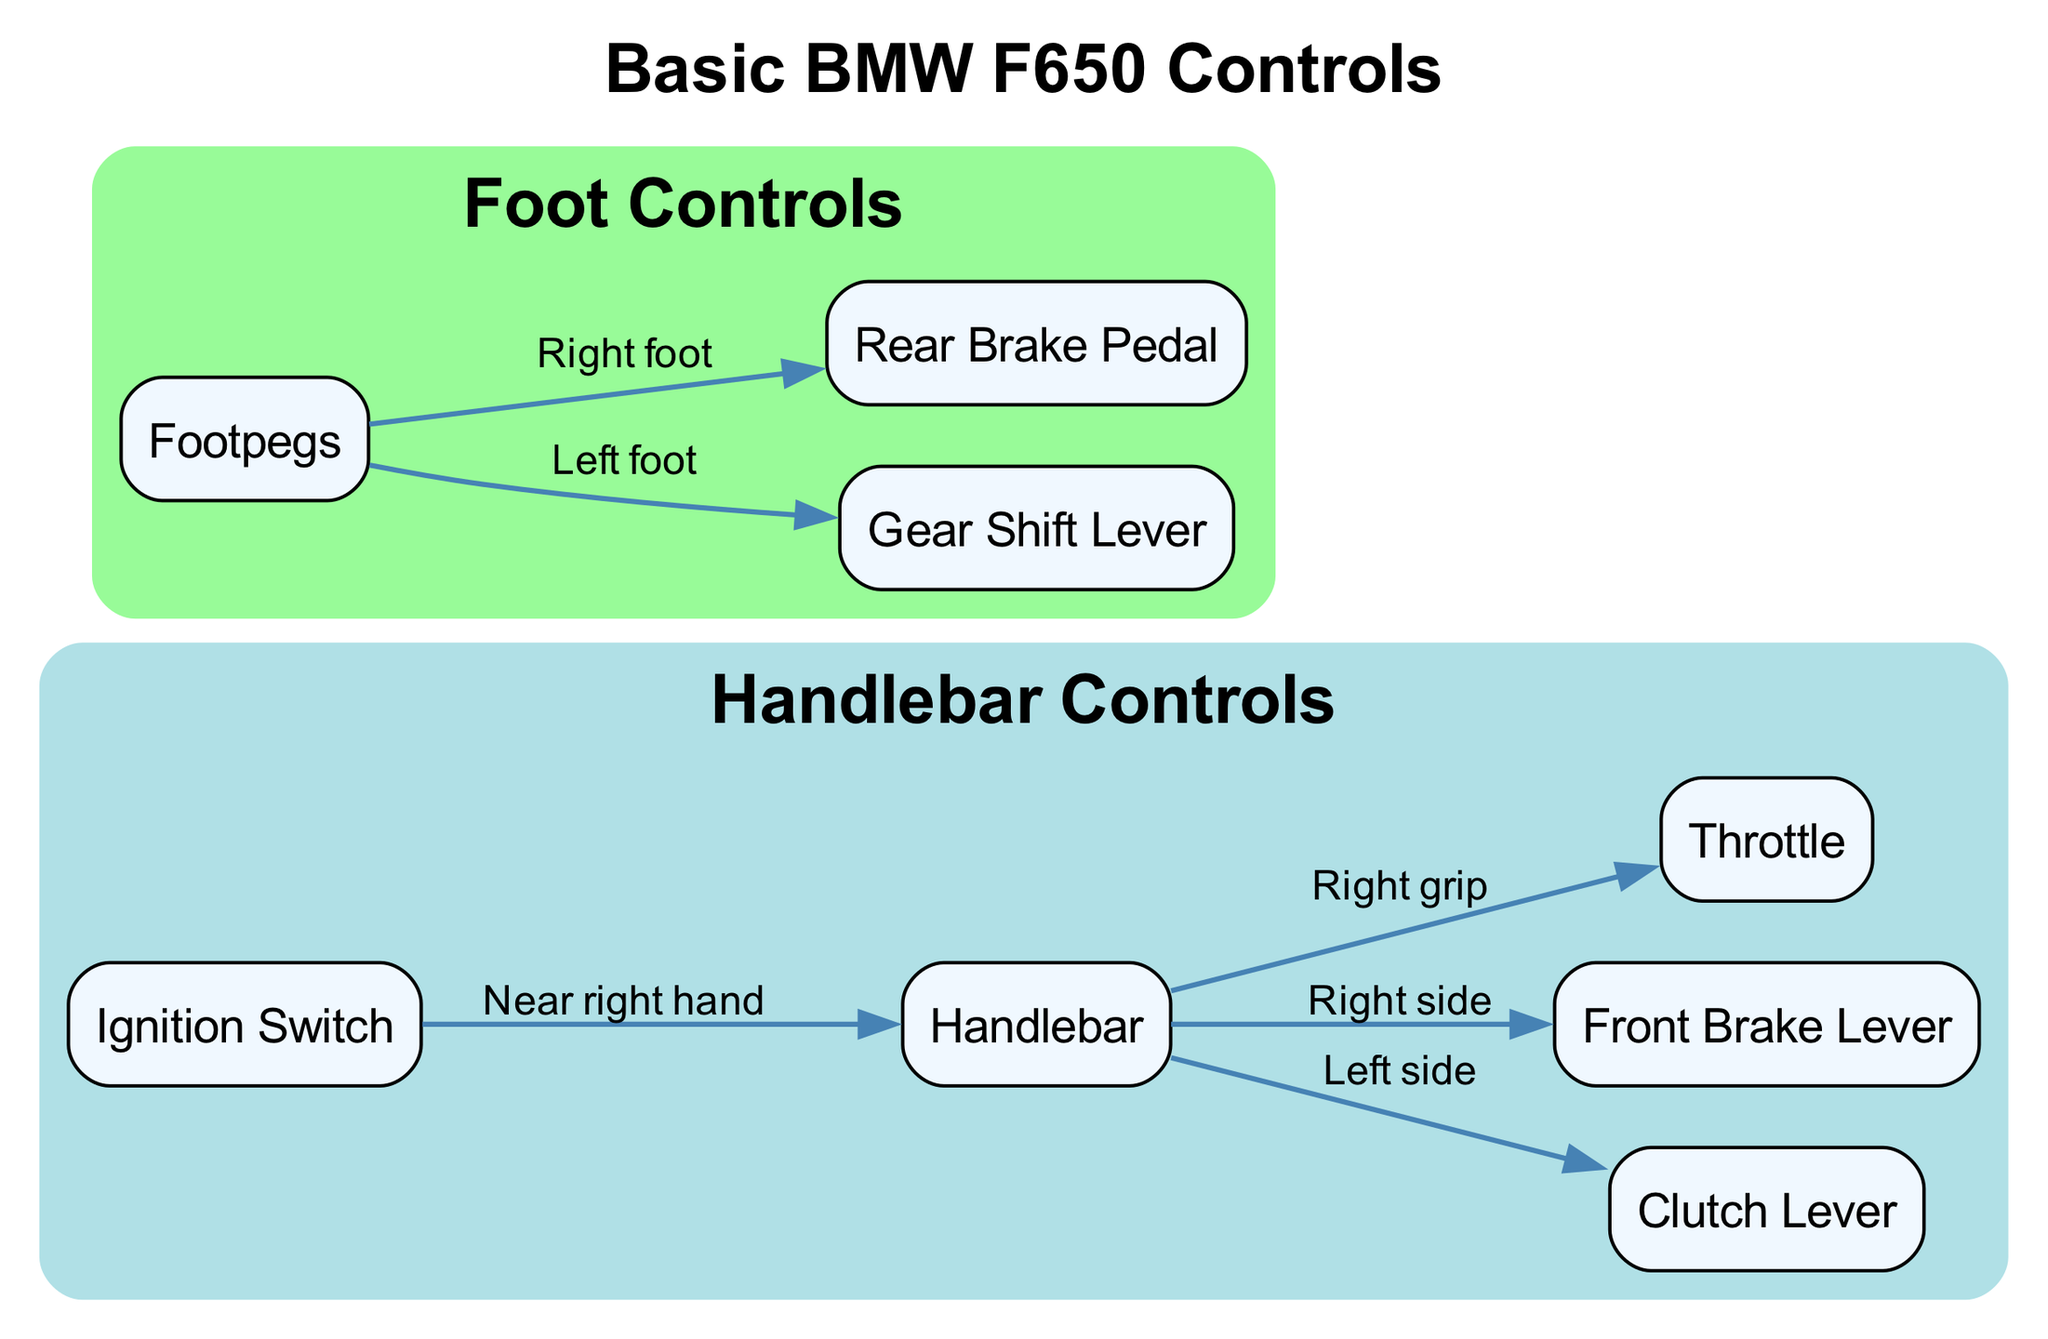What is the label of the control on the right grip? The diagram shows "Throttle" associated with the "Right grip" location on the handlebar.
Answer: Throttle How many nodes are in the diagram? Counting the nodes listed in the diagram, there are eight nodes total.
Answer: 8 Which lever is located on the left side of the handlebar? The diagram indicates that the "Clutch Lever" is connected as the control on the left side of the handlebar.
Answer: Clutch Lever What is the relationship between the footpegs and the gear shift lever? The diagram connects the "Footpegs" to the "Gear Shift Lever", indicating that the left foot operates the gear shift.
Answer: Left foot What is located near the right hand? The diagram specifies that the "Ignition Switch" is located near the right hand of the handlebar.
Answer: Ignition Switch Which control is used with the right foot? The diagram shows that the "Rear Brake Pedal" is the control operated by the right foot.
Answer: Rear Brake Pedal How many edges connect to handlebar controls? The edges depict three controls linked to the handlebar: Clutch Lever, Front Brake Lever, and Throttle, totaling three edges.
Answer: 3 Name the two grouped areas in the diagram. The diagram defines two main groups: "Handlebar Controls" and "Foot Controls".
Answer: Handlebar Controls, Foot Controls What connects footpegs to rear brake? The diagram shows that the right foot is responsible for operating the "Rear Brake Pedal", directly connecting them.
Answer: Right foot 